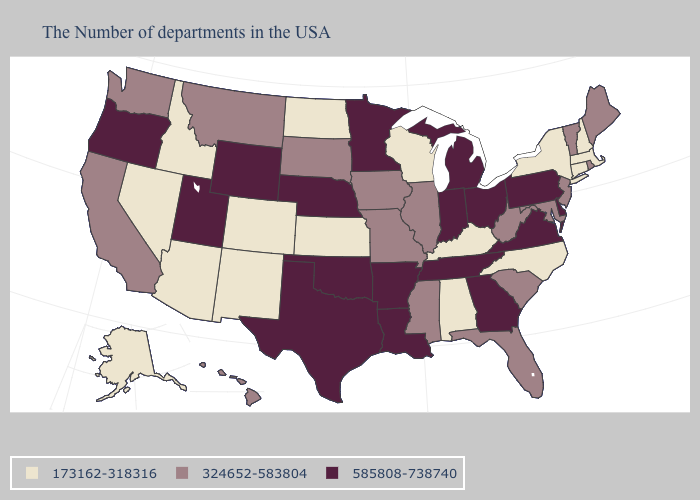Name the states that have a value in the range 173162-318316?
Give a very brief answer. Massachusetts, New Hampshire, Connecticut, New York, North Carolina, Kentucky, Alabama, Wisconsin, Kansas, North Dakota, Colorado, New Mexico, Arizona, Idaho, Nevada, Alaska. Does Missouri have the highest value in the MidWest?
Keep it brief. No. What is the lowest value in the MidWest?
Short answer required. 173162-318316. Does Colorado have the same value as New Hampshire?
Be succinct. Yes. Which states hav the highest value in the South?
Quick response, please. Delaware, Virginia, Georgia, Tennessee, Louisiana, Arkansas, Oklahoma, Texas. Name the states that have a value in the range 173162-318316?
Give a very brief answer. Massachusetts, New Hampshire, Connecticut, New York, North Carolina, Kentucky, Alabama, Wisconsin, Kansas, North Dakota, Colorado, New Mexico, Arizona, Idaho, Nevada, Alaska. Does Oklahoma have a lower value than Tennessee?
Be succinct. No. What is the value of Louisiana?
Answer briefly. 585808-738740. Among the states that border Arkansas , which have the highest value?
Give a very brief answer. Tennessee, Louisiana, Oklahoma, Texas. What is the lowest value in the MidWest?
Keep it brief. 173162-318316. Does Utah have the highest value in the West?
Quick response, please. Yes. What is the value of Wisconsin?
Short answer required. 173162-318316. Does the first symbol in the legend represent the smallest category?
Answer briefly. Yes. Does Texas have the same value as Hawaii?
Keep it brief. No. Among the states that border New Mexico , does Texas have the highest value?
Keep it brief. Yes. 